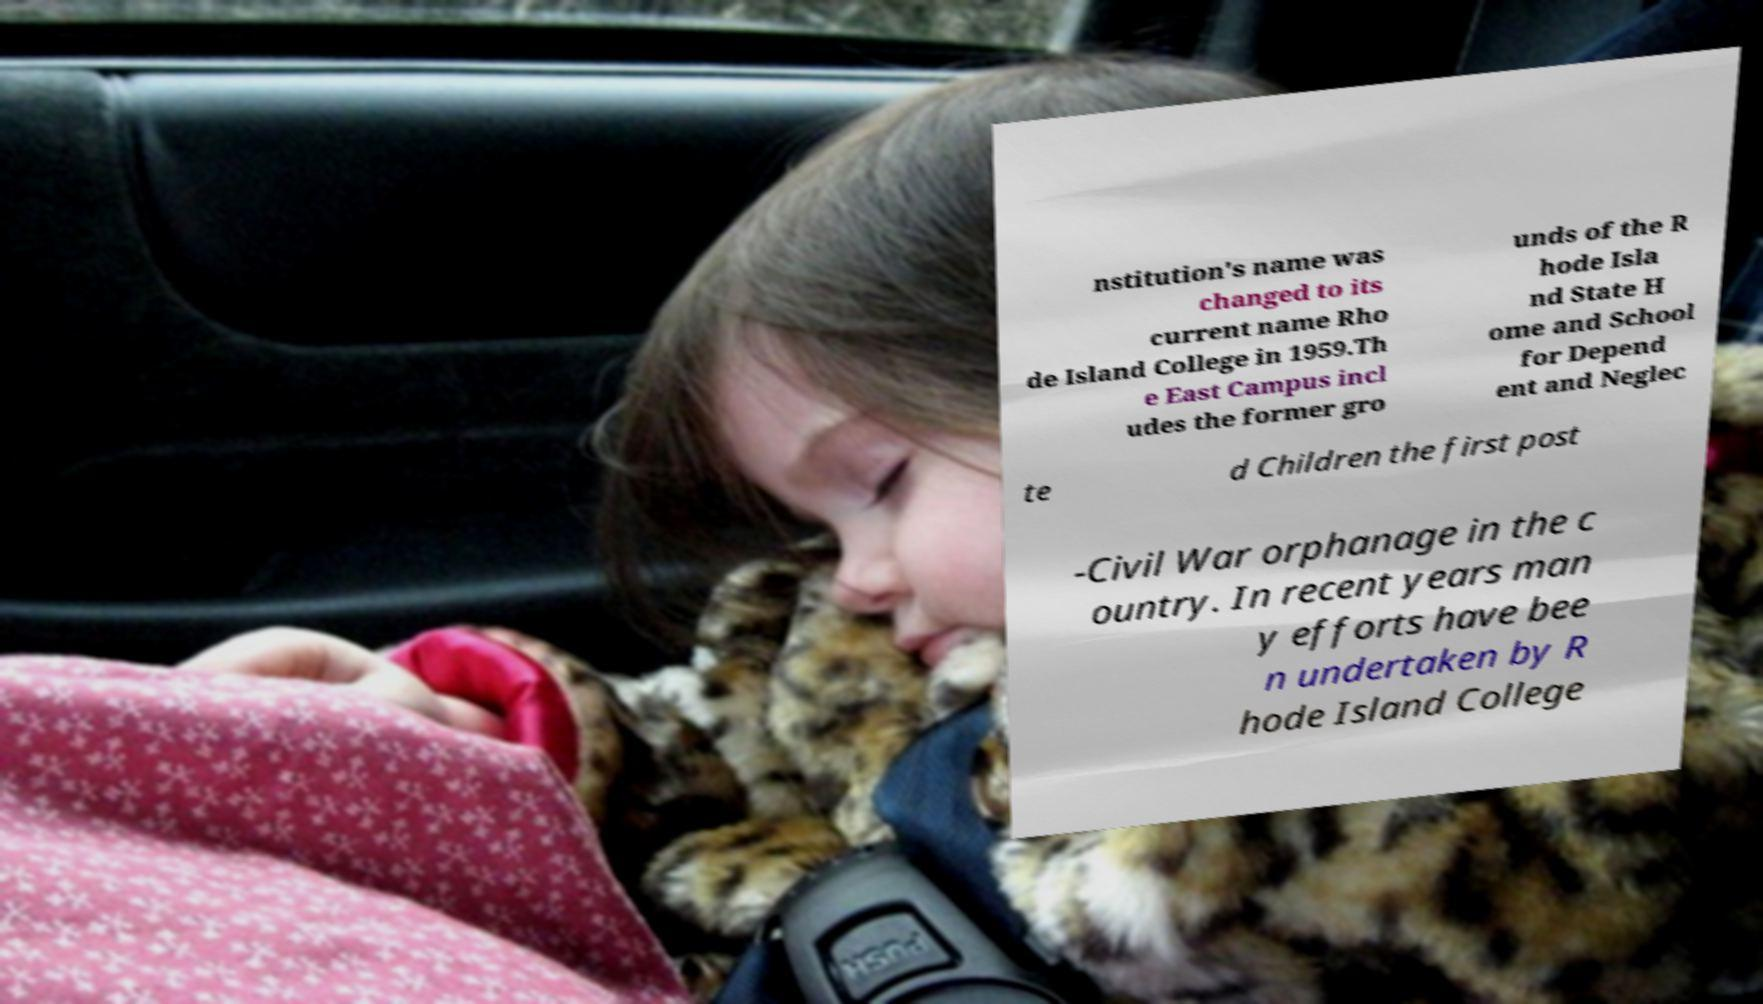There's text embedded in this image that I need extracted. Can you transcribe it verbatim? nstitution's name was changed to its current name Rho de Island College in 1959.Th e East Campus incl udes the former gro unds of the R hode Isla nd State H ome and School for Depend ent and Neglec te d Children the first post -Civil War orphanage in the c ountry. In recent years man y efforts have bee n undertaken by R hode Island College 